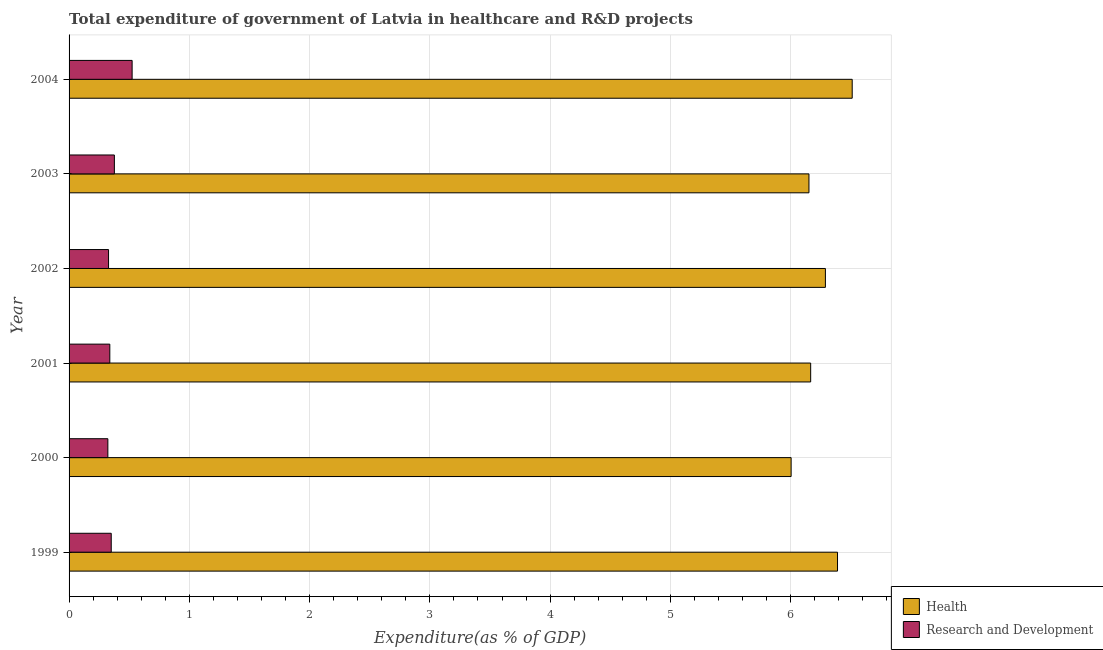How many different coloured bars are there?
Provide a short and direct response. 2. How many groups of bars are there?
Ensure brevity in your answer.  6. Are the number of bars on each tick of the Y-axis equal?
Provide a succinct answer. Yes. How many bars are there on the 3rd tick from the bottom?
Your answer should be compact. 2. In how many cases, is the number of bars for a given year not equal to the number of legend labels?
Your answer should be compact. 0. What is the expenditure in r&d in 2002?
Provide a short and direct response. 0.33. Across all years, what is the maximum expenditure in healthcare?
Your answer should be very brief. 6.51. Across all years, what is the minimum expenditure in healthcare?
Offer a very short reply. 6. In which year was the expenditure in r&d minimum?
Offer a very short reply. 2000. What is the total expenditure in healthcare in the graph?
Your answer should be very brief. 37.51. What is the difference between the expenditure in r&d in 2000 and that in 2003?
Your answer should be very brief. -0.05. What is the difference between the expenditure in r&d in 2002 and the expenditure in healthcare in 2001?
Your answer should be very brief. -5.84. What is the average expenditure in r&d per year?
Make the answer very short. 0.37. In the year 1999, what is the difference between the expenditure in r&d and expenditure in healthcare?
Ensure brevity in your answer.  -6.04. In how many years, is the expenditure in healthcare greater than 3 %?
Ensure brevity in your answer.  6. What is the ratio of the expenditure in healthcare in 1999 to that in 2002?
Offer a terse response. 1.02. Is the expenditure in healthcare in 2003 less than that in 2004?
Give a very brief answer. Yes. Is the difference between the expenditure in r&d in 1999 and 2001 greater than the difference between the expenditure in healthcare in 1999 and 2001?
Your answer should be very brief. No. What is the difference between the highest and the second highest expenditure in healthcare?
Your response must be concise. 0.12. In how many years, is the expenditure in healthcare greater than the average expenditure in healthcare taken over all years?
Provide a short and direct response. 3. Is the sum of the expenditure in healthcare in 1999 and 2001 greater than the maximum expenditure in r&d across all years?
Your answer should be compact. Yes. What does the 1st bar from the top in 2003 represents?
Offer a very short reply. Research and Development. What does the 2nd bar from the bottom in 2001 represents?
Keep it short and to the point. Research and Development. Are all the bars in the graph horizontal?
Your answer should be compact. Yes. Does the graph contain any zero values?
Provide a short and direct response. No. Where does the legend appear in the graph?
Your answer should be compact. Bottom right. How many legend labels are there?
Offer a terse response. 2. What is the title of the graph?
Give a very brief answer. Total expenditure of government of Latvia in healthcare and R&D projects. Does "Total Population" appear as one of the legend labels in the graph?
Provide a succinct answer. No. What is the label or title of the X-axis?
Your response must be concise. Expenditure(as % of GDP). What is the label or title of the Y-axis?
Your response must be concise. Year. What is the Expenditure(as % of GDP) in Health in 1999?
Keep it short and to the point. 6.39. What is the Expenditure(as % of GDP) of Research and Development in 1999?
Offer a terse response. 0.35. What is the Expenditure(as % of GDP) of Health in 2000?
Give a very brief answer. 6. What is the Expenditure(as % of GDP) of Research and Development in 2000?
Offer a terse response. 0.32. What is the Expenditure(as % of GDP) in Health in 2001?
Give a very brief answer. 6.17. What is the Expenditure(as % of GDP) in Research and Development in 2001?
Offer a terse response. 0.34. What is the Expenditure(as % of GDP) of Health in 2002?
Make the answer very short. 6.29. What is the Expenditure(as % of GDP) of Research and Development in 2002?
Keep it short and to the point. 0.33. What is the Expenditure(as % of GDP) of Health in 2003?
Give a very brief answer. 6.15. What is the Expenditure(as % of GDP) of Research and Development in 2003?
Keep it short and to the point. 0.38. What is the Expenditure(as % of GDP) of Health in 2004?
Your response must be concise. 6.51. What is the Expenditure(as % of GDP) in Research and Development in 2004?
Make the answer very short. 0.52. Across all years, what is the maximum Expenditure(as % of GDP) in Health?
Make the answer very short. 6.51. Across all years, what is the maximum Expenditure(as % of GDP) in Research and Development?
Make the answer very short. 0.52. Across all years, what is the minimum Expenditure(as % of GDP) in Health?
Offer a terse response. 6. Across all years, what is the minimum Expenditure(as % of GDP) of Research and Development?
Provide a succinct answer. 0.32. What is the total Expenditure(as % of GDP) in Health in the graph?
Give a very brief answer. 37.52. What is the total Expenditure(as % of GDP) in Research and Development in the graph?
Make the answer very short. 2.24. What is the difference between the Expenditure(as % of GDP) of Health in 1999 and that in 2000?
Keep it short and to the point. 0.39. What is the difference between the Expenditure(as % of GDP) in Research and Development in 1999 and that in 2000?
Provide a short and direct response. 0.03. What is the difference between the Expenditure(as % of GDP) of Health in 1999 and that in 2001?
Give a very brief answer. 0.22. What is the difference between the Expenditure(as % of GDP) of Research and Development in 1999 and that in 2001?
Make the answer very short. 0.01. What is the difference between the Expenditure(as % of GDP) in Health in 1999 and that in 2002?
Your answer should be very brief. 0.1. What is the difference between the Expenditure(as % of GDP) of Research and Development in 1999 and that in 2002?
Your answer should be very brief. 0.02. What is the difference between the Expenditure(as % of GDP) of Health in 1999 and that in 2003?
Your response must be concise. 0.24. What is the difference between the Expenditure(as % of GDP) in Research and Development in 1999 and that in 2003?
Your answer should be compact. -0.03. What is the difference between the Expenditure(as % of GDP) of Health in 1999 and that in 2004?
Make the answer very short. -0.12. What is the difference between the Expenditure(as % of GDP) of Research and Development in 1999 and that in 2004?
Keep it short and to the point. -0.17. What is the difference between the Expenditure(as % of GDP) of Health in 2000 and that in 2001?
Your answer should be very brief. -0.16. What is the difference between the Expenditure(as % of GDP) of Research and Development in 2000 and that in 2001?
Your answer should be compact. -0.02. What is the difference between the Expenditure(as % of GDP) in Health in 2000 and that in 2002?
Offer a very short reply. -0.28. What is the difference between the Expenditure(as % of GDP) in Research and Development in 2000 and that in 2002?
Your answer should be compact. -0.01. What is the difference between the Expenditure(as % of GDP) in Health in 2000 and that in 2003?
Provide a succinct answer. -0.15. What is the difference between the Expenditure(as % of GDP) of Research and Development in 2000 and that in 2003?
Give a very brief answer. -0.05. What is the difference between the Expenditure(as % of GDP) of Health in 2000 and that in 2004?
Offer a terse response. -0.51. What is the difference between the Expenditure(as % of GDP) of Research and Development in 2000 and that in 2004?
Give a very brief answer. -0.2. What is the difference between the Expenditure(as % of GDP) of Health in 2001 and that in 2002?
Make the answer very short. -0.12. What is the difference between the Expenditure(as % of GDP) of Research and Development in 2001 and that in 2002?
Keep it short and to the point. 0.01. What is the difference between the Expenditure(as % of GDP) in Health in 2001 and that in 2003?
Make the answer very short. 0.01. What is the difference between the Expenditure(as % of GDP) of Research and Development in 2001 and that in 2003?
Provide a succinct answer. -0.04. What is the difference between the Expenditure(as % of GDP) of Health in 2001 and that in 2004?
Your answer should be very brief. -0.35. What is the difference between the Expenditure(as % of GDP) of Research and Development in 2001 and that in 2004?
Provide a succinct answer. -0.19. What is the difference between the Expenditure(as % of GDP) of Health in 2002 and that in 2003?
Offer a terse response. 0.14. What is the difference between the Expenditure(as % of GDP) in Research and Development in 2002 and that in 2003?
Offer a terse response. -0.05. What is the difference between the Expenditure(as % of GDP) of Health in 2002 and that in 2004?
Give a very brief answer. -0.22. What is the difference between the Expenditure(as % of GDP) of Research and Development in 2002 and that in 2004?
Offer a very short reply. -0.2. What is the difference between the Expenditure(as % of GDP) of Health in 2003 and that in 2004?
Your response must be concise. -0.36. What is the difference between the Expenditure(as % of GDP) in Research and Development in 2003 and that in 2004?
Make the answer very short. -0.15. What is the difference between the Expenditure(as % of GDP) of Health in 1999 and the Expenditure(as % of GDP) of Research and Development in 2000?
Offer a very short reply. 6.07. What is the difference between the Expenditure(as % of GDP) of Health in 1999 and the Expenditure(as % of GDP) of Research and Development in 2001?
Your response must be concise. 6.05. What is the difference between the Expenditure(as % of GDP) of Health in 1999 and the Expenditure(as % of GDP) of Research and Development in 2002?
Your answer should be very brief. 6.06. What is the difference between the Expenditure(as % of GDP) in Health in 1999 and the Expenditure(as % of GDP) in Research and Development in 2003?
Offer a terse response. 6.01. What is the difference between the Expenditure(as % of GDP) of Health in 1999 and the Expenditure(as % of GDP) of Research and Development in 2004?
Your response must be concise. 5.87. What is the difference between the Expenditure(as % of GDP) of Health in 2000 and the Expenditure(as % of GDP) of Research and Development in 2001?
Offer a very short reply. 5.67. What is the difference between the Expenditure(as % of GDP) of Health in 2000 and the Expenditure(as % of GDP) of Research and Development in 2002?
Give a very brief answer. 5.68. What is the difference between the Expenditure(as % of GDP) in Health in 2000 and the Expenditure(as % of GDP) in Research and Development in 2003?
Offer a terse response. 5.63. What is the difference between the Expenditure(as % of GDP) in Health in 2000 and the Expenditure(as % of GDP) in Research and Development in 2004?
Ensure brevity in your answer.  5.48. What is the difference between the Expenditure(as % of GDP) in Health in 2001 and the Expenditure(as % of GDP) in Research and Development in 2002?
Make the answer very short. 5.84. What is the difference between the Expenditure(as % of GDP) in Health in 2001 and the Expenditure(as % of GDP) in Research and Development in 2003?
Give a very brief answer. 5.79. What is the difference between the Expenditure(as % of GDP) in Health in 2001 and the Expenditure(as % of GDP) in Research and Development in 2004?
Keep it short and to the point. 5.64. What is the difference between the Expenditure(as % of GDP) of Health in 2002 and the Expenditure(as % of GDP) of Research and Development in 2003?
Ensure brevity in your answer.  5.91. What is the difference between the Expenditure(as % of GDP) in Health in 2002 and the Expenditure(as % of GDP) in Research and Development in 2004?
Offer a very short reply. 5.76. What is the difference between the Expenditure(as % of GDP) of Health in 2003 and the Expenditure(as % of GDP) of Research and Development in 2004?
Offer a terse response. 5.63. What is the average Expenditure(as % of GDP) of Health per year?
Provide a short and direct response. 6.25. What is the average Expenditure(as % of GDP) in Research and Development per year?
Ensure brevity in your answer.  0.37. In the year 1999, what is the difference between the Expenditure(as % of GDP) of Health and Expenditure(as % of GDP) of Research and Development?
Your response must be concise. 6.04. In the year 2000, what is the difference between the Expenditure(as % of GDP) in Health and Expenditure(as % of GDP) in Research and Development?
Your answer should be compact. 5.68. In the year 2001, what is the difference between the Expenditure(as % of GDP) in Health and Expenditure(as % of GDP) in Research and Development?
Your response must be concise. 5.83. In the year 2002, what is the difference between the Expenditure(as % of GDP) of Health and Expenditure(as % of GDP) of Research and Development?
Ensure brevity in your answer.  5.96. In the year 2003, what is the difference between the Expenditure(as % of GDP) in Health and Expenditure(as % of GDP) in Research and Development?
Make the answer very short. 5.78. In the year 2004, what is the difference between the Expenditure(as % of GDP) in Health and Expenditure(as % of GDP) in Research and Development?
Provide a succinct answer. 5.99. What is the ratio of the Expenditure(as % of GDP) of Health in 1999 to that in 2000?
Your answer should be very brief. 1.06. What is the ratio of the Expenditure(as % of GDP) in Research and Development in 1999 to that in 2000?
Your answer should be very brief. 1.09. What is the ratio of the Expenditure(as % of GDP) of Health in 1999 to that in 2001?
Keep it short and to the point. 1.04. What is the ratio of the Expenditure(as % of GDP) in Research and Development in 1999 to that in 2001?
Provide a succinct answer. 1.03. What is the ratio of the Expenditure(as % of GDP) in Research and Development in 1999 to that in 2002?
Give a very brief answer. 1.07. What is the ratio of the Expenditure(as % of GDP) of Health in 1999 to that in 2003?
Keep it short and to the point. 1.04. What is the ratio of the Expenditure(as % of GDP) in Research and Development in 1999 to that in 2003?
Keep it short and to the point. 0.93. What is the ratio of the Expenditure(as % of GDP) in Health in 1999 to that in 2004?
Provide a short and direct response. 0.98. What is the ratio of the Expenditure(as % of GDP) of Research and Development in 1999 to that in 2004?
Offer a very short reply. 0.67. What is the ratio of the Expenditure(as % of GDP) of Health in 2000 to that in 2001?
Give a very brief answer. 0.97. What is the ratio of the Expenditure(as % of GDP) of Research and Development in 2000 to that in 2001?
Provide a succinct answer. 0.95. What is the ratio of the Expenditure(as % of GDP) in Health in 2000 to that in 2002?
Provide a succinct answer. 0.95. What is the ratio of the Expenditure(as % of GDP) in Research and Development in 2000 to that in 2002?
Your response must be concise. 0.98. What is the ratio of the Expenditure(as % of GDP) of Health in 2000 to that in 2003?
Ensure brevity in your answer.  0.98. What is the ratio of the Expenditure(as % of GDP) of Research and Development in 2000 to that in 2003?
Your answer should be compact. 0.86. What is the ratio of the Expenditure(as % of GDP) of Health in 2000 to that in 2004?
Provide a short and direct response. 0.92. What is the ratio of the Expenditure(as % of GDP) in Research and Development in 2000 to that in 2004?
Keep it short and to the point. 0.62. What is the ratio of the Expenditure(as % of GDP) of Health in 2001 to that in 2002?
Give a very brief answer. 0.98. What is the ratio of the Expenditure(as % of GDP) of Research and Development in 2001 to that in 2002?
Keep it short and to the point. 1.03. What is the ratio of the Expenditure(as % of GDP) of Health in 2001 to that in 2003?
Your answer should be compact. 1. What is the ratio of the Expenditure(as % of GDP) of Research and Development in 2001 to that in 2003?
Make the answer very short. 0.9. What is the ratio of the Expenditure(as % of GDP) in Health in 2001 to that in 2004?
Offer a terse response. 0.95. What is the ratio of the Expenditure(as % of GDP) in Research and Development in 2001 to that in 2004?
Offer a terse response. 0.65. What is the ratio of the Expenditure(as % of GDP) of Health in 2002 to that in 2003?
Offer a very short reply. 1.02. What is the ratio of the Expenditure(as % of GDP) of Research and Development in 2002 to that in 2003?
Your answer should be very brief. 0.87. What is the ratio of the Expenditure(as % of GDP) of Health in 2002 to that in 2004?
Ensure brevity in your answer.  0.97. What is the ratio of the Expenditure(as % of GDP) in Research and Development in 2002 to that in 2004?
Your answer should be compact. 0.63. What is the ratio of the Expenditure(as % of GDP) in Health in 2003 to that in 2004?
Your answer should be very brief. 0.94. What is the ratio of the Expenditure(as % of GDP) of Research and Development in 2003 to that in 2004?
Offer a terse response. 0.72. What is the difference between the highest and the second highest Expenditure(as % of GDP) in Health?
Offer a very short reply. 0.12. What is the difference between the highest and the second highest Expenditure(as % of GDP) of Research and Development?
Provide a succinct answer. 0.15. What is the difference between the highest and the lowest Expenditure(as % of GDP) of Health?
Ensure brevity in your answer.  0.51. What is the difference between the highest and the lowest Expenditure(as % of GDP) in Research and Development?
Give a very brief answer. 0.2. 